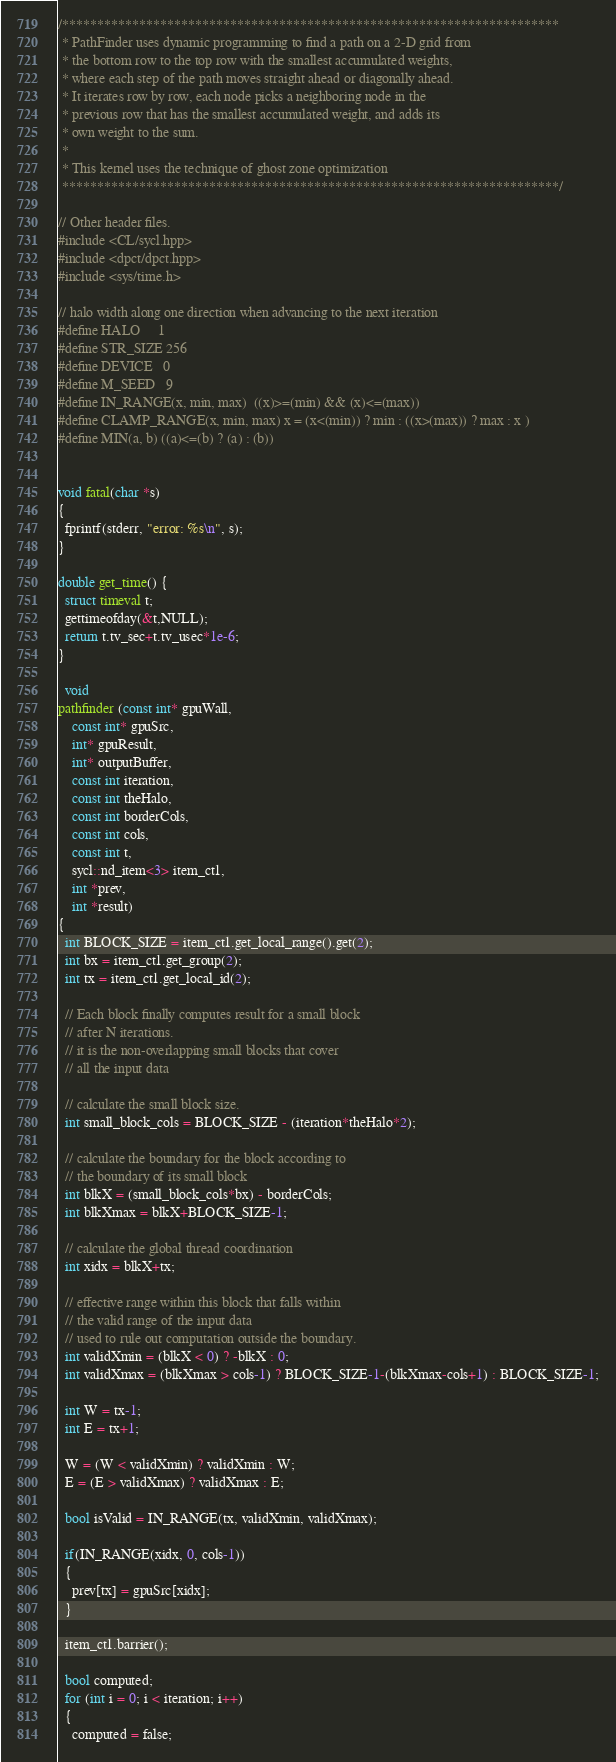Convert code to text. <code><loc_0><loc_0><loc_500><loc_500><_C++_>/***********************************************************************
 * PathFinder uses dynamic programming to find a path on a 2-D grid from
 * the bottom row to the top row with the smallest accumulated weights,
 * where each step of the path moves straight ahead or diagonally ahead.
 * It iterates row by row, each node picks a neighboring node in the
 * previous row that has the smallest accumulated weight, and adds its
 * own weight to the sum.
 *
 * This kernel uses the technique of ghost zone optimization
 ***********************************************************************/

// Other header files.
#include <CL/sycl.hpp>
#include <dpct/dpct.hpp>
#include <sys/time.h>

// halo width along one direction when advancing to the next iteration
#define HALO     1
#define STR_SIZE 256
#define DEVICE   0
#define M_SEED   9
#define IN_RANGE(x, min, max)  ((x)>=(min) && (x)<=(max))
#define CLAMP_RANGE(x, min, max) x = (x<(min)) ? min : ((x>(max)) ? max : x )
#define MIN(a, b) ((a)<=(b) ? (a) : (b))


void fatal(char *s)
{
  fprintf(stderr, "error: %s\n", s);
}

double get_time() {
  struct timeval t;
  gettimeofday(&t,NULL);
  return t.tv_sec+t.tv_usec*1e-6;
}

  void
pathfinder (const int* gpuWall, 
    const int* gpuSrc, 
    int* gpuResult, 
    int* outputBuffer, 
    const int iteration, 
    const int theHalo,
    const int borderCols, 
    const int cols,
    const int t,
    sycl::nd_item<3> item_ct1,
    int *prev,
    int *result)
{
  int BLOCK_SIZE = item_ct1.get_local_range().get(2);
  int bx = item_ct1.get_group(2);
  int tx = item_ct1.get_local_id(2);

  // Each block finally computes result for a small block
  // after N iterations.
  // it is the non-overlapping small blocks that cover
  // all the input data

  // calculate the small block size.
  int small_block_cols = BLOCK_SIZE - (iteration*theHalo*2);

  // calculate the boundary for the block according to
  // the boundary of its small block
  int blkX = (small_block_cols*bx) - borderCols;
  int blkXmax = blkX+BLOCK_SIZE-1;

  // calculate the global thread coordination
  int xidx = blkX+tx;

  // effective range within this block that falls within
  // the valid range of the input data
  // used to rule out computation outside the boundary.
  int validXmin = (blkX < 0) ? -blkX : 0;
  int validXmax = (blkXmax > cols-1) ? BLOCK_SIZE-1-(blkXmax-cols+1) : BLOCK_SIZE-1;

  int W = tx-1;
  int E = tx+1;

  W = (W < validXmin) ? validXmin : W;
  E = (E > validXmax) ? validXmax : E;

  bool isValid = IN_RANGE(tx, validXmin, validXmax);

  if(IN_RANGE(xidx, 0, cols-1))
  {
    prev[tx] = gpuSrc[xidx];
  }

  item_ct1.barrier();

  bool computed;
  for (int i = 0; i < iteration; i++)
  {
    computed = false;
</code> 